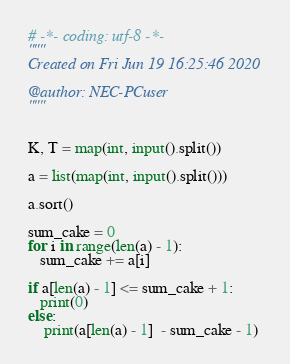Convert code to text. <code><loc_0><loc_0><loc_500><loc_500><_Python_># -*- coding: utf-8 -*-
"""
Created on Fri Jun 19 16:25:46 2020

@author: NEC-PCuser
"""


K, T = map(int, input().split())

a = list(map(int, input().split()))

a.sort()

sum_cake = 0
for i in range(len(a) - 1):
   sum_cake += a[i]

if a[len(a) - 1] <= sum_cake + 1:
   print(0)
else:
    print(a[len(a) - 1]  - sum_cake - 1)</code> 